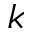Convert formula to latex. <formula><loc_0><loc_0><loc_500><loc_500>k</formula> 